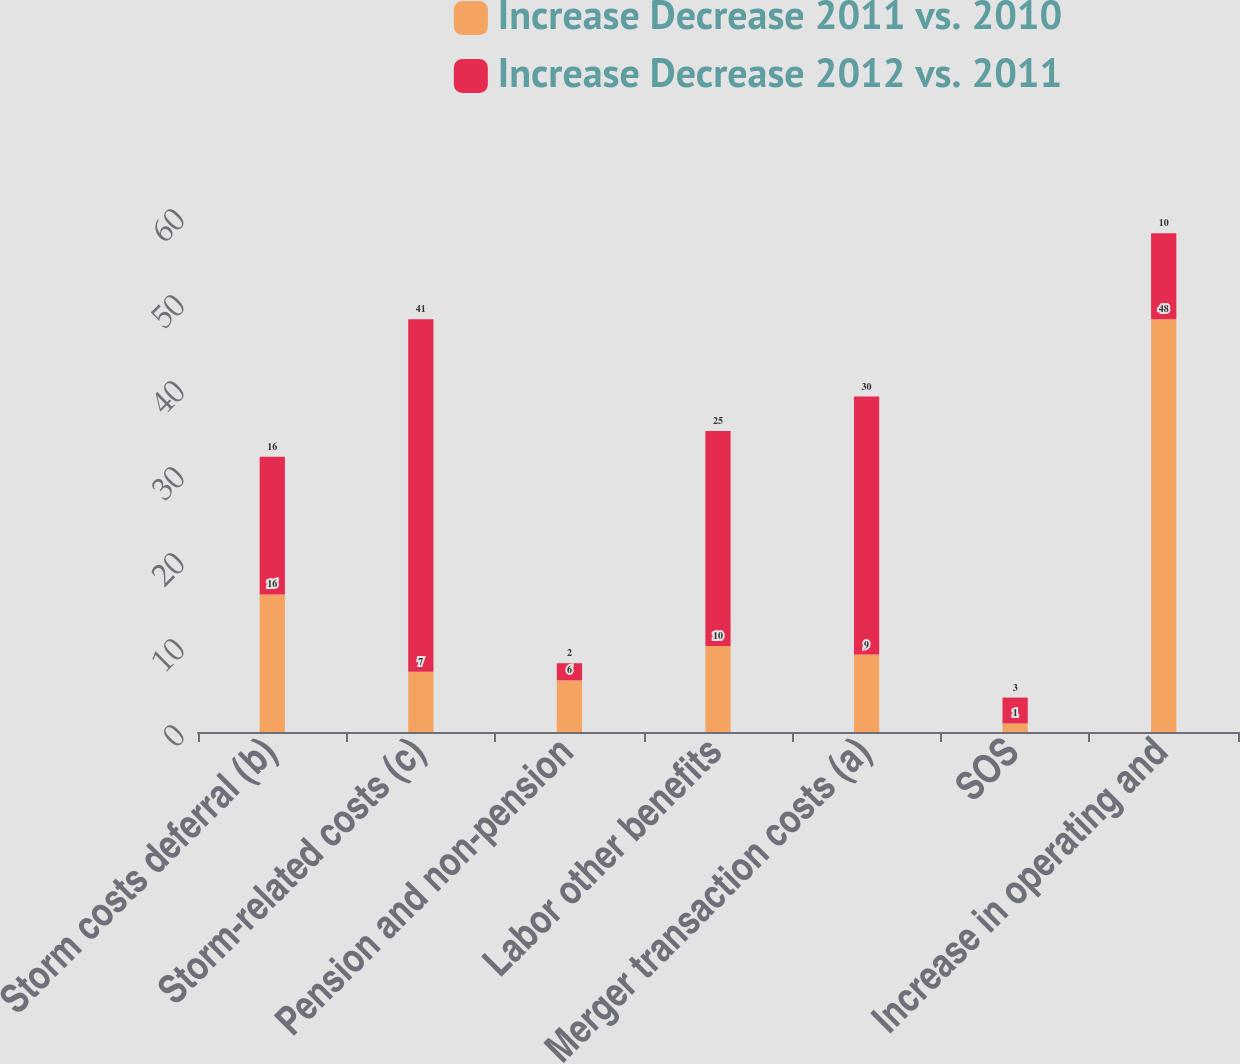Convert chart to OTSL. <chart><loc_0><loc_0><loc_500><loc_500><stacked_bar_chart><ecel><fcel>Storm costs deferral (b)<fcel>Storm-related costs (c)<fcel>Pension and non-pension<fcel>Labor other benefits<fcel>Merger transaction costs (a)<fcel>SOS<fcel>Increase in operating and<nl><fcel>Increase Decrease 2011 vs. 2010<fcel>16<fcel>7<fcel>6<fcel>10<fcel>9<fcel>1<fcel>48<nl><fcel>Increase Decrease 2012 vs. 2011<fcel>16<fcel>41<fcel>2<fcel>25<fcel>30<fcel>3<fcel>10<nl></chart> 